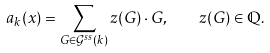<formula> <loc_0><loc_0><loc_500><loc_500>a _ { k } ( x ) = \sum _ { G \in \mathcal { G } ^ { s s } ( k ) } z ( G ) \cdot G , \quad z ( G ) \in \mathbb { Q } .</formula> 